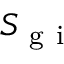Convert formula to latex. <formula><loc_0><loc_0><loc_500><loc_500>S _ { g i }</formula> 